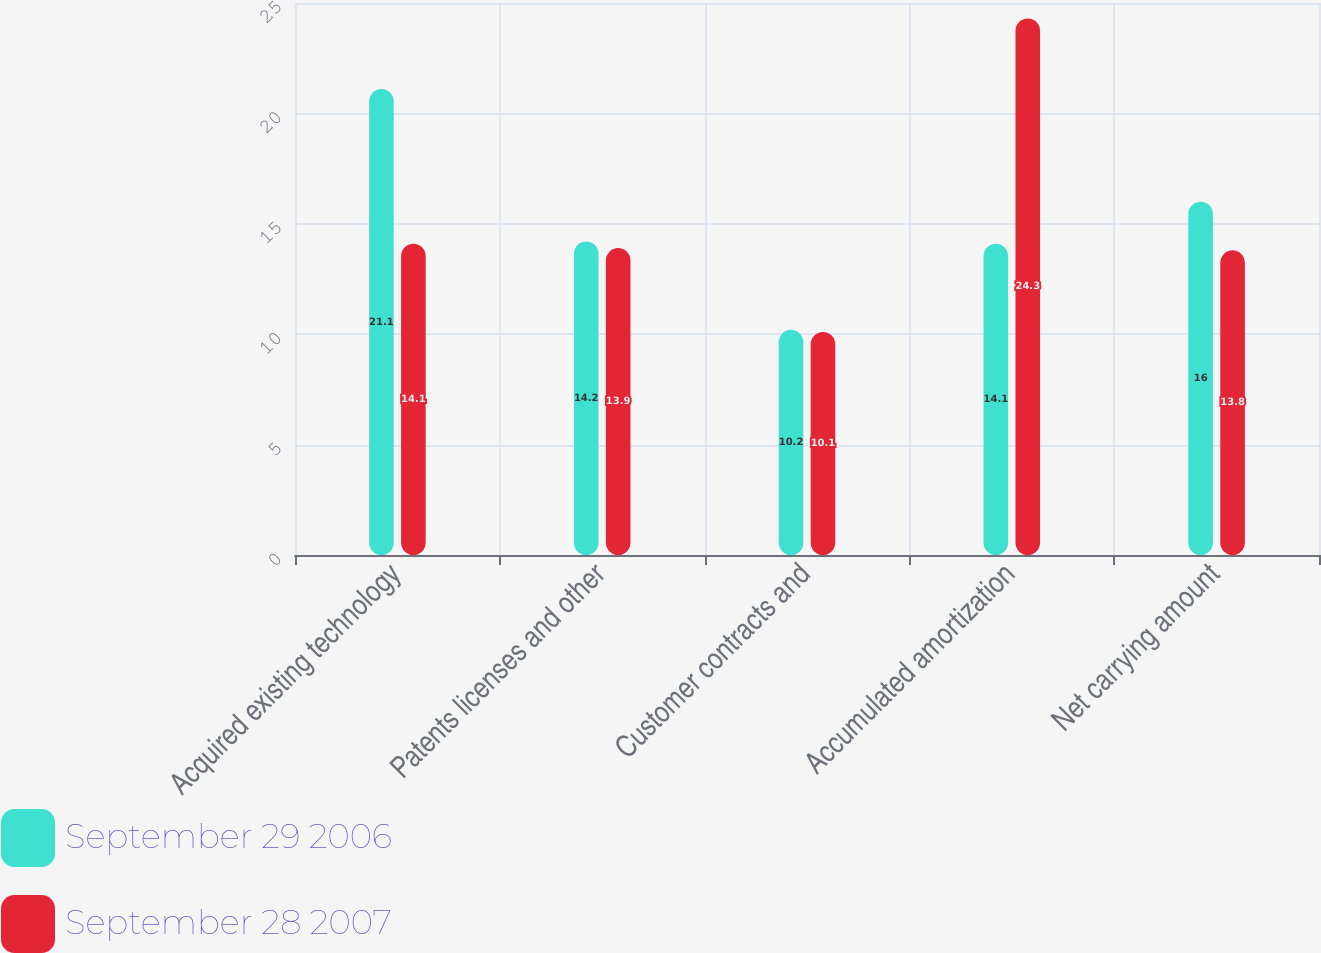<chart> <loc_0><loc_0><loc_500><loc_500><stacked_bar_chart><ecel><fcel>Acquired existing technology<fcel>Patents licenses and other<fcel>Customer contracts and<fcel>Accumulated amortization<fcel>Net carrying amount<nl><fcel>September 29 2006<fcel>21.1<fcel>14.2<fcel>10.2<fcel>14.1<fcel>16<nl><fcel>September 28 2007<fcel>14.1<fcel>13.9<fcel>10.1<fcel>24.3<fcel>13.8<nl></chart> 